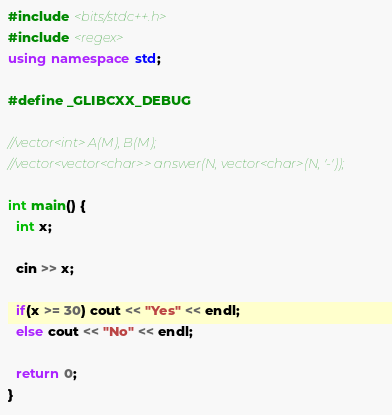<code> <loc_0><loc_0><loc_500><loc_500><_C++_>#include <bits/stdc++.h>
#include <regex>
using namespace std;

#define _GLIBCXX_DEBUG

//vector<int> A(M), B(M);
//vector<vector<char>> answer(N, vector<char>(N, '-'));

int main() {
  int x;
  
  cin >> x;
  
  if(x >= 30) cout << "Yes" << endl;
  else cout << "No" << endl;
  
  return 0;
}</code> 